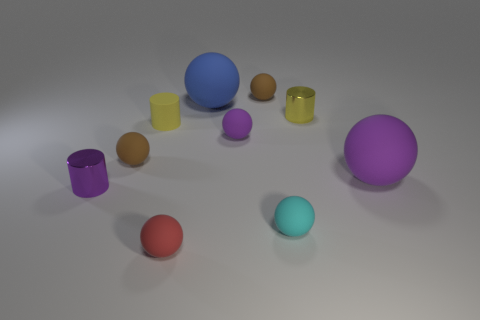Subtract all purple cylinders. How many cylinders are left? 2 Subtract all small purple cylinders. How many cylinders are left? 2 How many purple balls must be subtracted to get 1 purple balls? 1 Subtract all blue cylinders. Subtract all brown cubes. How many cylinders are left? 3 Subtract all gray cylinders. How many brown balls are left? 2 Subtract all tiny brown matte balls. Subtract all purple rubber objects. How many objects are left? 6 Add 1 blue balls. How many blue balls are left? 2 Add 4 tiny red things. How many tiny red things exist? 5 Subtract 0 red cylinders. How many objects are left? 10 Subtract all cylinders. How many objects are left? 7 